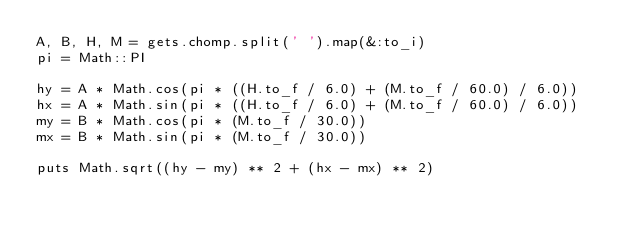Convert code to text. <code><loc_0><loc_0><loc_500><loc_500><_Ruby_>A, B, H, M = gets.chomp.split(' ').map(&:to_i)
pi = Math::PI

hy = A * Math.cos(pi * ((H.to_f / 6.0) + (M.to_f / 60.0) / 6.0))
hx = A * Math.sin(pi * ((H.to_f / 6.0) + (M.to_f / 60.0) / 6.0))
my = B * Math.cos(pi * (M.to_f / 30.0))
mx = B * Math.sin(pi * (M.to_f / 30.0))

puts Math.sqrt((hy - my) ** 2 + (hx - mx) ** 2)</code> 